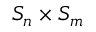Convert formula to latex. <formula><loc_0><loc_0><loc_500><loc_500>S _ { n } \times S _ { m }</formula> 